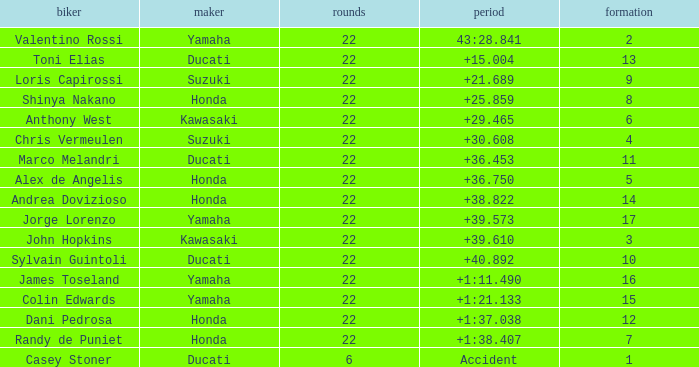What is Honda's highest grid with a time of +1:38.407? 7.0. 